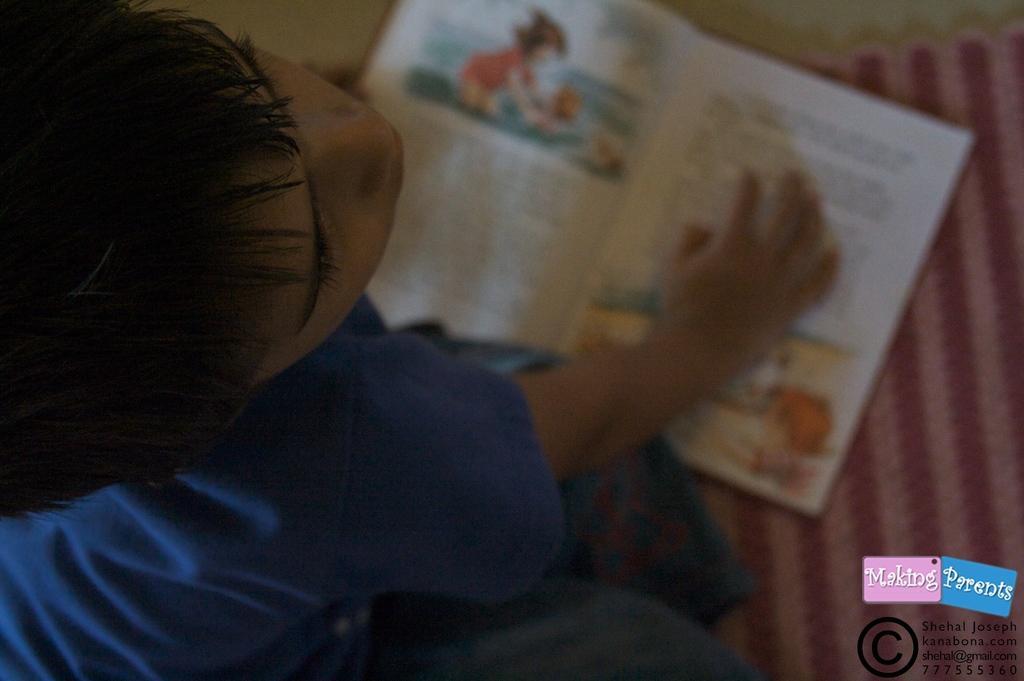Can you describe this image briefly? In this image we can see a kid and a book on the mat in front of the kid. 